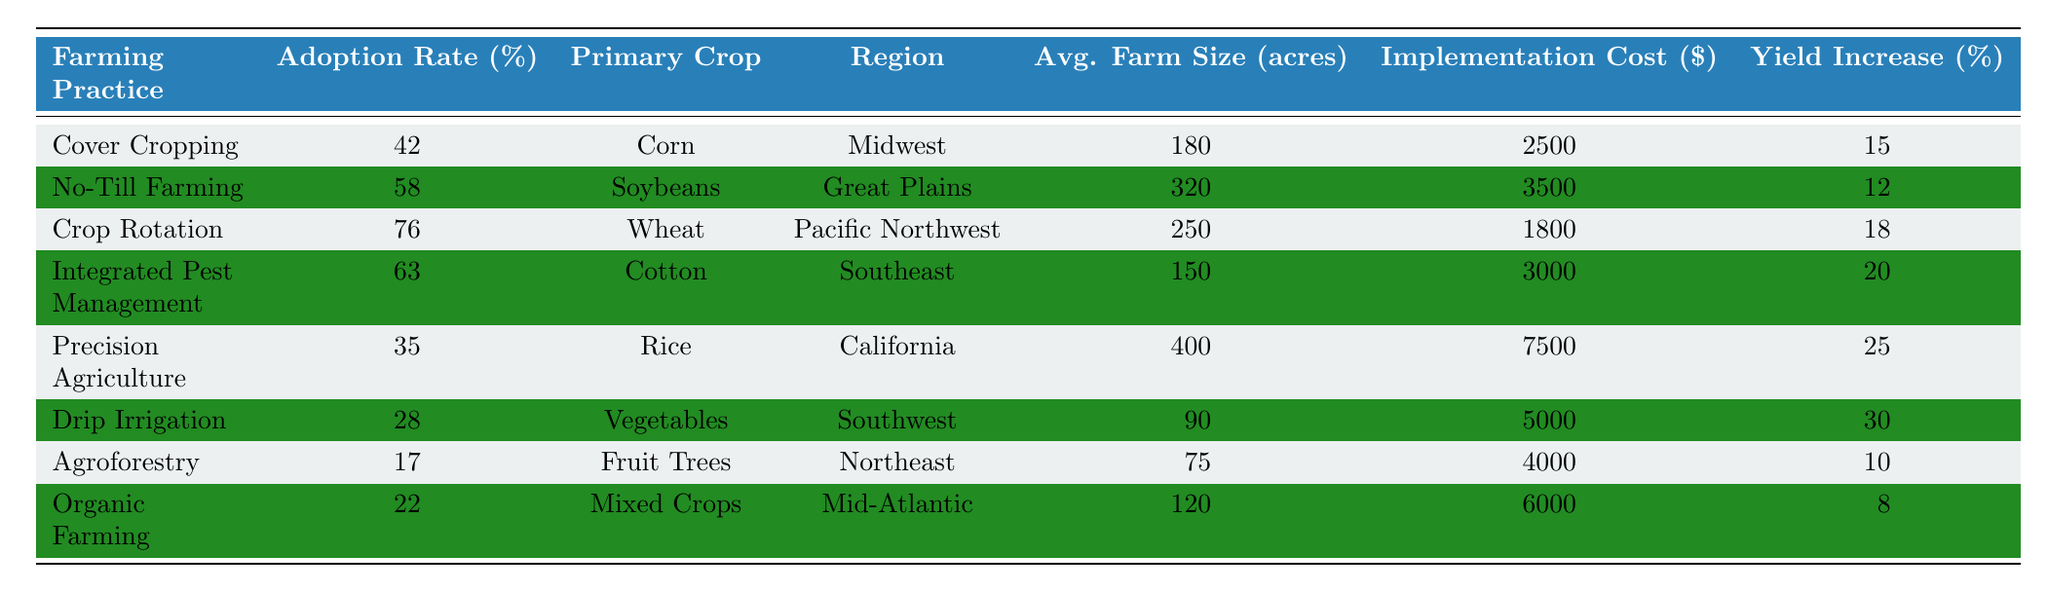What is the adoption rate of Crop Rotation? The table shows that the adoption rate for Crop Rotation is listed directly in the "Adoption Rate (%)" column next to the "Farming Practice" entry for Crop Rotation. It is 76%.
Answer: 76% Which farming practice has the highest yield increase? By examining the "Yield Increase (%)" column, we find that Precision Agriculture has the highest yield increase at 25%.
Answer: 25% Is Drip Irrigation more widely adopted than Agroforestry? We can compare the adoption rates of Drip Irrigation and Agroforestry. Drip Irrigation has a rate of 28%, whereas Agroforestry's adoption rate is 17%. Therefore, Drip Irrigation is more widely adopted.
Answer: Yes What is the average farm size for the farming practices implemented in the Pacific Northwest? The farming practice in the Pacific Northwest is Crop Rotation. Looking at the "Avg. Farm Size (acres)" column for this practice, we see it is 250 acres. There are no other practices listed for this region, so that is the average.
Answer: 250 acres Which farming practice has the highest adoption rate in the Southeast region? From the table, Integrated Pest Management has an adoption rate of 63%, which is higher than all practices listed for the Southeast region.
Answer: Integrated Pest Management How much lower is the adoption rate of Organic Farming compared to No-Till Farming? The adoption rate of Organic Farming is 22%, and the rate for No-Till Farming is 58%. To find the difference, we subtract 22 from 58, giving us 36%.
Answer: 36% Are there any farming practices with adoption rates under 30%? Looking through the "Adoption Rate (%)" column, we can identify that both Drip Irrigation (28%) and Agroforestry (17%) have adoption rates under 30%.
Answer: Yes What is the cost difference between implementing Cover Cropping and Crop Rotation? The implementation costs are $2500 for Cover Cropping and $1800 for Crop Rotation. To find the difference, we subtract $1800 from $2500, which equals $700.
Answer: $700 Which region has the highest average farm size, and what is it? The table shows that Carolina's Precision Agriculture has the highest average farm size at 400 acres. This is higher than average sizes in all other regions listed.
Answer: 400 acres If all farming practices increased their adoption rates by 10%, which farming practice would then have the highest adoption rate? We calculate the new adoption rates by adding 10% to each existing rate. After checking the modified rates, Crop Rotation would have the highest at 86% (originally 76%).
Answer: Crop Rotation 